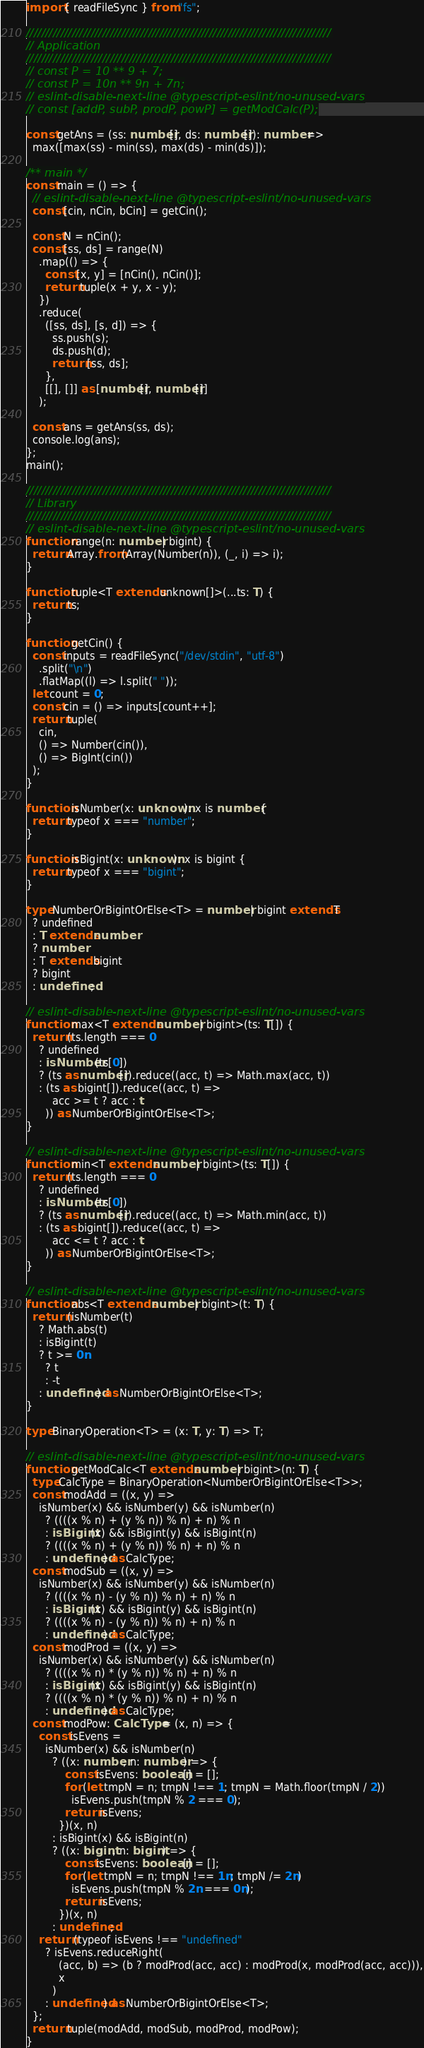Convert code to text. <code><loc_0><loc_0><loc_500><loc_500><_TypeScript_>import { readFileSync } from "fs";

////////////////////////////////////////////////////////////////////////////////
// Application
////////////////////////////////////////////////////////////////////////////////
// const P = 10 ** 9 + 7;
// const P = 10n ** 9n + 7n;
// eslint-disable-next-line @typescript-eslint/no-unused-vars
// const [addP, subP, prodP, powP] = getModCalc(P);

const getAns = (ss: number[], ds: number[]): number =>
  max([max(ss) - min(ss), max(ds) - min(ds)]);

/** main */
const main = () => {
  // eslint-disable-next-line @typescript-eslint/no-unused-vars
  const [cin, nCin, bCin] = getCin();

  const N = nCin();
  const [ss, ds] = range(N)
    .map(() => {
      const [x, y] = [nCin(), nCin()];
      return tuple(x + y, x - y);
    })
    .reduce(
      ([ss, ds], [s, d]) => {
        ss.push(s);
        ds.push(d);
        return [ss, ds];
      },
      [[], []] as [number[], number[]]
    );

  const ans = getAns(ss, ds);
  console.log(ans);
};
main();

////////////////////////////////////////////////////////////////////////////////
// Library
////////////////////////////////////////////////////////////////////////////////
// eslint-disable-next-line @typescript-eslint/no-unused-vars
function range(n: number | bigint) {
  return Array.from(Array(Number(n)), (_, i) => i);
}

function tuple<T extends unknown[]>(...ts: T) {
  return ts;
}

function getCin() {
  const inputs = readFileSync("/dev/stdin", "utf-8")
    .split("\n")
    .flatMap((l) => l.split(" "));
  let count = 0;
  const cin = () => inputs[count++];
  return tuple(
    cin,
    () => Number(cin()),
    () => BigInt(cin())
  );
}

function isNumber(x: unknown): x is number {
  return typeof x === "number";
}

function isBigint(x: unknown): x is bigint {
  return typeof x === "bigint";
}

type NumberOrBigintOrElse<T> = number | bigint extends T
  ? undefined
  : T extends number
  ? number
  : T extends bigint
  ? bigint
  : undefined;

// eslint-disable-next-line @typescript-eslint/no-unused-vars
function max<T extends number | bigint>(ts: T[]) {
  return (ts.length === 0
    ? undefined
    : isNumber(ts[0])
    ? (ts as number[]).reduce((acc, t) => Math.max(acc, t))
    : (ts as bigint[]).reduce((acc, t) =>
        acc >= t ? acc : t
      )) as NumberOrBigintOrElse<T>;
}

// eslint-disable-next-line @typescript-eslint/no-unused-vars
function min<T extends number | bigint>(ts: T[]) {
  return (ts.length === 0
    ? undefined
    : isNumber(ts[0])
    ? (ts as number[]).reduce((acc, t) => Math.min(acc, t))
    : (ts as bigint[]).reduce((acc, t) =>
        acc <= t ? acc : t
      )) as NumberOrBigintOrElse<T>;
}

// eslint-disable-next-line @typescript-eslint/no-unused-vars
function abs<T extends number | bigint>(t: T) {
  return (isNumber(t)
    ? Math.abs(t)
    : isBigint(t)
    ? t >= 0n
      ? t
      : -t
    : undefined) as NumberOrBigintOrElse<T>;
}

type BinaryOperation<T> = (x: T, y: T) => T;

// eslint-disable-next-line @typescript-eslint/no-unused-vars
function getModCalc<T extends number | bigint>(n: T) {
  type CalcType = BinaryOperation<NumberOrBigintOrElse<T>>;
  const modAdd = ((x, y) =>
    isNumber(x) && isNumber(y) && isNumber(n)
      ? ((((x % n) + (y % n)) % n) + n) % n
      : isBigint(x) && isBigint(y) && isBigint(n)
      ? ((((x % n) + (y % n)) % n) + n) % n
      : undefined) as CalcType;
  const modSub = ((x, y) =>
    isNumber(x) && isNumber(y) && isNumber(n)
      ? ((((x % n) - (y % n)) % n) + n) % n
      : isBigint(x) && isBigint(y) && isBigint(n)
      ? ((((x % n) - (y % n)) % n) + n) % n
      : undefined) as CalcType;
  const modProd = ((x, y) =>
    isNumber(x) && isNumber(y) && isNumber(n)
      ? ((((x % n) * (y % n)) % n) + n) % n
      : isBigint(x) && isBigint(y) && isBigint(n)
      ? ((((x % n) * (y % n)) % n) + n) % n
      : undefined) as CalcType;
  const modPow: CalcType = (x, n) => {
    const isEvens =
      isNumber(x) && isNumber(n)
        ? ((x: number, n: number) => {
            const isEvens: boolean[] = [];
            for (let tmpN = n; tmpN !== 1; tmpN = Math.floor(tmpN / 2))
              isEvens.push(tmpN % 2 === 0);
            return isEvens;
          })(x, n)
        : isBigint(x) && isBigint(n)
        ? ((x: bigint, n: bigint) => {
            const isEvens: boolean[] = [];
            for (let tmpN = n; tmpN !== 1n; tmpN /= 2n)
              isEvens.push(tmpN % 2n === 0n);
            return isEvens;
          })(x, n)
        : undefined;
    return (typeof isEvens !== "undefined"
      ? isEvens.reduceRight(
          (acc, b) => (b ? modProd(acc, acc) : modProd(x, modProd(acc, acc))),
          x
        )
      : undefined) as NumberOrBigintOrElse<T>;
  };
  return tuple(modAdd, modSub, modProd, modPow);
}
</code> 